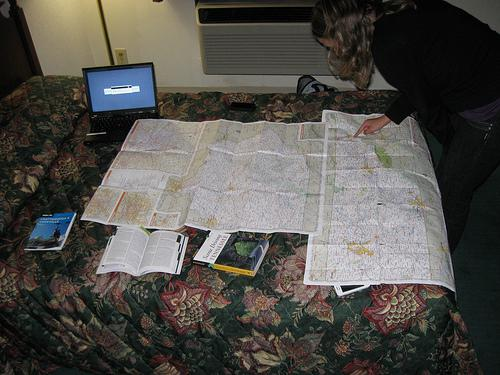Question: why is the map on the bed?
Choices:
A. So she know where to go.
B. So she can find it.
C. So she can see it easily.
D. So she can get a better look at it.
Answer with the letter. Answer: D Question: what is on the bed?
Choices:
A. Sheets.
B. A comforter.
C. A map.
D. Pillows.
Answer with the letter. Answer: C Question: who is reading the map?
Choices:
A. A girl.
B. A boy.
C. A human.
D. A man.
Answer with the letter. Answer: A Question: how many books are on the bed?
Choices:
A. Two.
B. Six.
C. Four.
D. Three.
Answer with the letter. Answer: D 